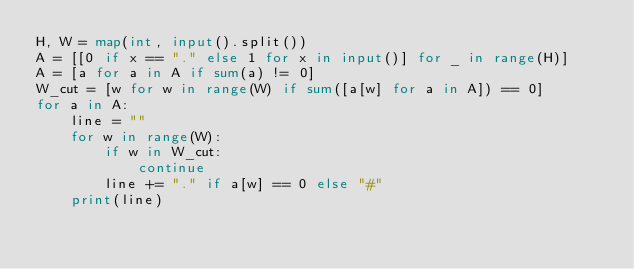<code> <loc_0><loc_0><loc_500><loc_500><_Python_>H, W = map(int, input().split())
A = [[0 if x == "." else 1 for x in input()] for _ in range(H)]
A = [a for a in A if sum(a) != 0]
W_cut = [w for w in range(W) if sum([a[w] for a in A]) == 0]
for a in A:
    line = ""
    for w in range(W):
        if w in W_cut:
            continue
        line += "." if a[w] == 0 else "#"
    print(line)
</code> 